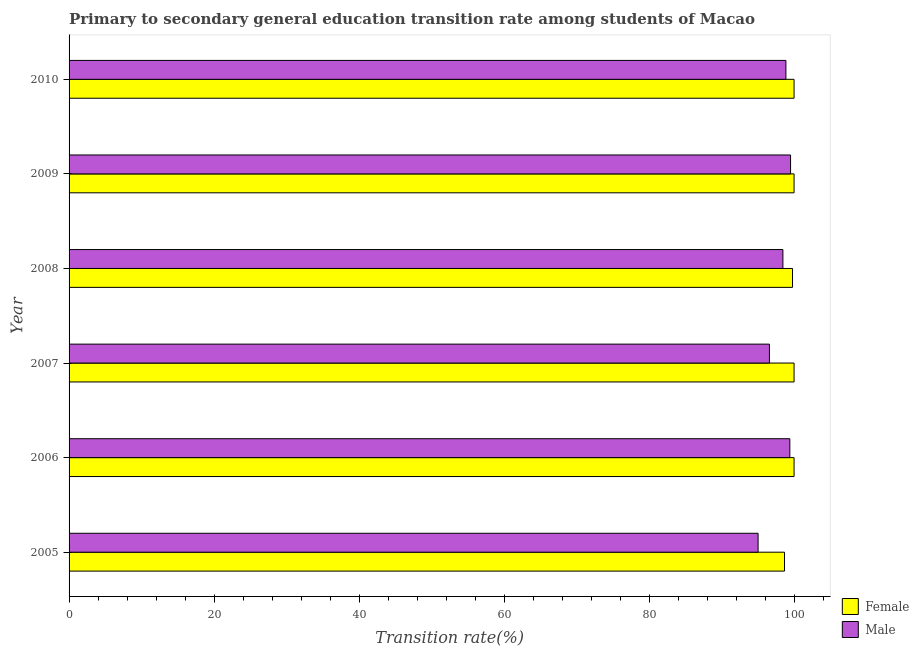Are the number of bars on each tick of the Y-axis equal?
Offer a terse response. Yes. How many bars are there on the 2nd tick from the top?
Ensure brevity in your answer.  2. How many bars are there on the 6th tick from the bottom?
Offer a terse response. 2. In how many cases, is the number of bars for a given year not equal to the number of legend labels?
Ensure brevity in your answer.  0. What is the transition rate among male students in 2010?
Ensure brevity in your answer.  98.88. Across all years, what is the minimum transition rate among male students?
Ensure brevity in your answer.  95.04. In which year was the transition rate among female students minimum?
Make the answer very short. 2005. What is the total transition rate among female students in the graph?
Give a very brief answer. 598.47. What is the difference between the transition rate among male students in 2009 and that in 2010?
Offer a very short reply. 0.64. What is the difference between the transition rate among male students in 2009 and the transition rate among female students in 2006?
Give a very brief answer. -0.48. What is the average transition rate among male students per year?
Offer a very short reply. 97.99. In the year 2007, what is the difference between the transition rate among female students and transition rate among male students?
Offer a terse response. 3.4. In how many years, is the transition rate among female students greater than 4 %?
Your answer should be compact. 6. Is the transition rate among male students in 2006 less than that in 2010?
Your answer should be very brief. No. Is the difference between the transition rate among female students in 2009 and 2010 greater than the difference between the transition rate among male students in 2009 and 2010?
Make the answer very short. No. What is the difference between the highest and the second highest transition rate among female students?
Provide a succinct answer. 0. What is the difference between the highest and the lowest transition rate among female students?
Your answer should be compact. 1.32. What does the 2nd bar from the top in 2006 represents?
Provide a succinct answer. Female. Are all the bars in the graph horizontal?
Give a very brief answer. Yes. How many years are there in the graph?
Provide a succinct answer. 6. What is the difference between two consecutive major ticks on the X-axis?
Keep it short and to the point. 20. Are the values on the major ticks of X-axis written in scientific E-notation?
Make the answer very short. No. Does the graph contain grids?
Offer a very short reply. No. How are the legend labels stacked?
Your answer should be compact. Vertical. What is the title of the graph?
Keep it short and to the point. Primary to secondary general education transition rate among students of Macao. Does "Number of departures" appear as one of the legend labels in the graph?
Ensure brevity in your answer.  No. What is the label or title of the X-axis?
Give a very brief answer. Transition rate(%). What is the label or title of the Y-axis?
Offer a very short reply. Year. What is the Transition rate(%) in Female in 2005?
Your response must be concise. 98.68. What is the Transition rate(%) of Male in 2005?
Your answer should be very brief. 95.04. What is the Transition rate(%) in Female in 2006?
Offer a terse response. 100. What is the Transition rate(%) in Male in 2006?
Your answer should be very brief. 99.42. What is the Transition rate(%) in Male in 2007?
Keep it short and to the point. 96.6. What is the Transition rate(%) of Female in 2008?
Offer a very short reply. 99.79. What is the Transition rate(%) of Male in 2008?
Provide a short and direct response. 98.46. What is the Transition rate(%) of Male in 2009?
Your response must be concise. 99.52. What is the Transition rate(%) of Male in 2010?
Ensure brevity in your answer.  98.88. Across all years, what is the maximum Transition rate(%) of Female?
Provide a short and direct response. 100. Across all years, what is the maximum Transition rate(%) of Male?
Ensure brevity in your answer.  99.52. Across all years, what is the minimum Transition rate(%) of Female?
Offer a terse response. 98.68. Across all years, what is the minimum Transition rate(%) in Male?
Give a very brief answer. 95.04. What is the total Transition rate(%) in Female in the graph?
Your answer should be very brief. 598.47. What is the total Transition rate(%) of Male in the graph?
Offer a very short reply. 587.91. What is the difference between the Transition rate(%) in Female in 2005 and that in 2006?
Your answer should be compact. -1.32. What is the difference between the Transition rate(%) in Male in 2005 and that in 2006?
Provide a succinct answer. -4.38. What is the difference between the Transition rate(%) of Female in 2005 and that in 2007?
Offer a terse response. -1.32. What is the difference between the Transition rate(%) of Male in 2005 and that in 2007?
Provide a succinct answer. -1.57. What is the difference between the Transition rate(%) of Female in 2005 and that in 2008?
Keep it short and to the point. -1.1. What is the difference between the Transition rate(%) in Male in 2005 and that in 2008?
Your answer should be very brief. -3.42. What is the difference between the Transition rate(%) of Female in 2005 and that in 2009?
Provide a short and direct response. -1.32. What is the difference between the Transition rate(%) in Male in 2005 and that in 2009?
Keep it short and to the point. -4.48. What is the difference between the Transition rate(%) in Female in 2005 and that in 2010?
Keep it short and to the point. -1.32. What is the difference between the Transition rate(%) in Male in 2005 and that in 2010?
Your response must be concise. -3.84. What is the difference between the Transition rate(%) in Male in 2006 and that in 2007?
Offer a terse response. 2.81. What is the difference between the Transition rate(%) in Female in 2006 and that in 2008?
Give a very brief answer. 0.21. What is the difference between the Transition rate(%) of Male in 2006 and that in 2008?
Offer a very short reply. 0.95. What is the difference between the Transition rate(%) in Female in 2006 and that in 2009?
Your response must be concise. 0. What is the difference between the Transition rate(%) in Male in 2006 and that in 2009?
Offer a terse response. -0.1. What is the difference between the Transition rate(%) of Female in 2006 and that in 2010?
Make the answer very short. 0. What is the difference between the Transition rate(%) of Male in 2006 and that in 2010?
Make the answer very short. 0.54. What is the difference between the Transition rate(%) of Female in 2007 and that in 2008?
Offer a very short reply. 0.21. What is the difference between the Transition rate(%) of Male in 2007 and that in 2008?
Provide a succinct answer. -1.86. What is the difference between the Transition rate(%) in Male in 2007 and that in 2009?
Your answer should be compact. -2.91. What is the difference between the Transition rate(%) in Male in 2007 and that in 2010?
Your answer should be compact. -2.27. What is the difference between the Transition rate(%) in Female in 2008 and that in 2009?
Make the answer very short. -0.21. What is the difference between the Transition rate(%) of Male in 2008 and that in 2009?
Keep it short and to the point. -1.06. What is the difference between the Transition rate(%) in Female in 2008 and that in 2010?
Make the answer very short. -0.21. What is the difference between the Transition rate(%) in Male in 2008 and that in 2010?
Make the answer very short. -0.41. What is the difference between the Transition rate(%) in Female in 2009 and that in 2010?
Your answer should be compact. 0. What is the difference between the Transition rate(%) of Male in 2009 and that in 2010?
Your answer should be very brief. 0.64. What is the difference between the Transition rate(%) in Female in 2005 and the Transition rate(%) in Male in 2006?
Provide a short and direct response. -0.73. What is the difference between the Transition rate(%) of Female in 2005 and the Transition rate(%) of Male in 2007?
Offer a very short reply. 2.08. What is the difference between the Transition rate(%) of Female in 2005 and the Transition rate(%) of Male in 2008?
Your response must be concise. 0.22. What is the difference between the Transition rate(%) of Female in 2005 and the Transition rate(%) of Male in 2009?
Your answer should be very brief. -0.83. What is the difference between the Transition rate(%) in Female in 2005 and the Transition rate(%) in Male in 2010?
Ensure brevity in your answer.  -0.19. What is the difference between the Transition rate(%) in Female in 2006 and the Transition rate(%) in Male in 2007?
Give a very brief answer. 3.4. What is the difference between the Transition rate(%) of Female in 2006 and the Transition rate(%) of Male in 2008?
Your answer should be compact. 1.54. What is the difference between the Transition rate(%) of Female in 2006 and the Transition rate(%) of Male in 2009?
Ensure brevity in your answer.  0.48. What is the difference between the Transition rate(%) in Female in 2006 and the Transition rate(%) in Male in 2010?
Offer a terse response. 1.12. What is the difference between the Transition rate(%) of Female in 2007 and the Transition rate(%) of Male in 2008?
Your answer should be very brief. 1.54. What is the difference between the Transition rate(%) of Female in 2007 and the Transition rate(%) of Male in 2009?
Offer a terse response. 0.48. What is the difference between the Transition rate(%) in Female in 2007 and the Transition rate(%) in Male in 2010?
Give a very brief answer. 1.12. What is the difference between the Transition rate(%) in Female in 2008 and the Transition rate(%) in Male in 2009?
Your response must be concise. 0.27. What is the difference between the Transition rate(%) of Female in 2008 and the Transition rate(%) of Male in 2010?
Provide a succinct answer. 0.91. What is the difference between the Transition rate(%) in Female in 2009 and the Transition rate(%) in Male in 2010?
Give a very brief answer. 1.12. What is the average Transition rate(%) of Female per year?
Make the answer very short. 99.75. What is the average Transition rate(%) of Male per year?
Give a very brief answer. 97.99. In the year 2005, what is the difference between the Transition rate(%) of Female and Transition rate(%) of Male?
Make the answer very short. 3.65. In the year 2006, what is the difference between the Transition rate(%) in Female and Transition rate(%) in Male?
Ensure brevity in your answer.  0.58. In the year 2007, what is the difference between the Transition rate(%) in Female and Transition rate(%) in Male?
Offer a very short reply. 3.4. In the year 2008, what is the difference between the Transition rate(%) in Female and Transition rate(%) in Male?
Your answer should be compact. 1.33. In the year 2009, what is the difference between the Transition rate(%) of Female and Transition rate(%) of Male?
Your answer should be very brief. 0.48. In the year 2010, what is the difference between the Transition rate(%) of Female and Transition rate(%) of Male?
Offer a terse response. 1.12. What is the ratio of the Transition rate(%) of Male in 2005 to that in 2006?
Keep it short and to the point. 0.96. What is the ratio of the Transition rate(%) in Female in 2005 to that in 2007?
Offer a terse response. 0.99. What is the ratio of the Transition rate(%) of Male in 2005 to that in 2007?
Make the answer very short. 0.98. What is the ratio of the Transition rate(%) in Female in 2005 to that in 2008?
Give a very brief answer. 0.99. What is the ratio of the Transition rate(%) in Male in 2005 to that in 2008?
Keep it short and to the point. 0.97. What is the ratio of the Transition rate(%) of Female in 2005 to that in 2009?
Offer a terse response. 0.99. What is the ratio of the Transition rate(%) in Male in 2005 to that in 2009?
Your answer should be compact. 0.95. What is the ratio of the Transition rate(%) of Male in 2005 to that in 2010?
Provide a short and direct response. 0.96. What is the ratio of the Transition rate(%) of Female in 2006 to that in 2007?
Keep it short and to the point. 1. What is the ratio of the Transition rate(%) of Male in 2006 to that in 2007?
Make the answer very short. 1.03. What is the ratio of the Transition rate(%) in Female in 2006 to that in 2008?
Make the answer very short. 1. What is the ratio of the Transition rate(%) of Male in 2006 to that in 2008?
Your answer should be very brief. 1.01. What is the ratio of the Transition rate(%) in Male in 2006 to that in 2010?
Your response must be concise. 1.01. What is the ratio of the Transition rate(%) in Female in 2007 to that in 2008?
Offer a terse response. 1. What is the ratio of the Transition rate(%) in Male in 2007 to that in 2008?
Give a very brief answer. 0.98. What is the ratio of the Transition rate(%) in Male in 2007 to that in 2009?
Ensure brevity in your answer.  0.97. What is the ratio of the Transition rate(%) in Male in 2007 to that in 2010?
Your answer should be compact. 0.98. What is the ratio of the Transition rate(%) of Male in 2008 to that in 2010?
Your answer should be very brief. 1. What is the ratio of the Transition rate(%) in Female in 2009 to that in 2010?
Your response must be concise. 1. What is the difference between the highest and the second highest Transition rate(%) of Male?
Ensure brevity in your answer.  0.1. What is the difference between the highest and the lowest Transition rate(%) of Female?
Provide a short and direct response. 1.32. What is the difference between the highest and the lowest Transition rate(%) of Male?
Offer a terse response. 4.48. 